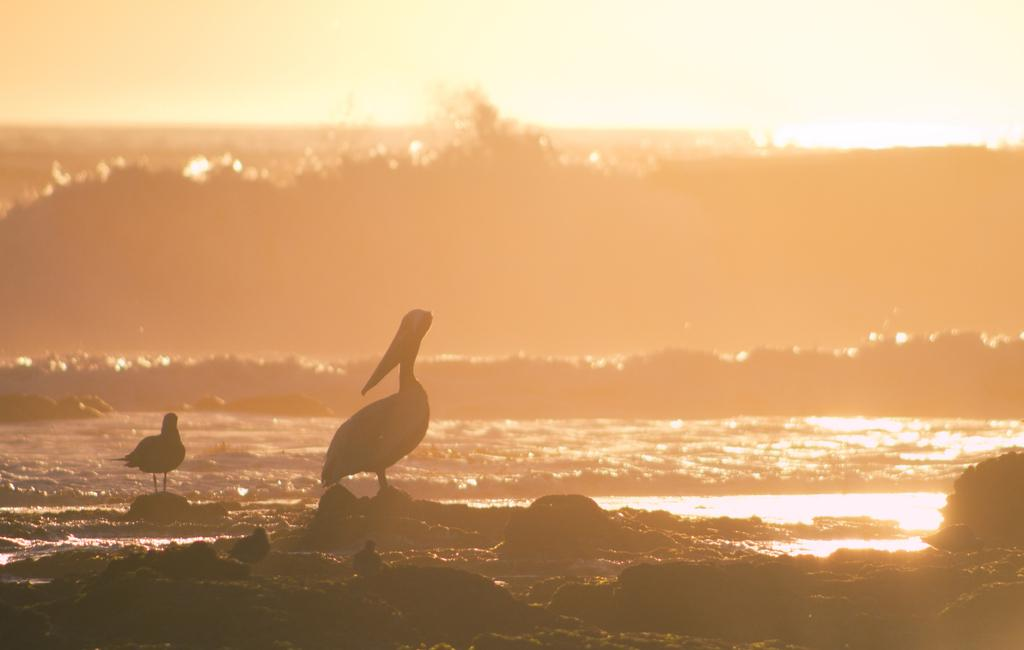What animals can be seen on the stones in the image? There are birds on the stones in the image. What can be observed in the water in the image? There are waves in the water in the image. What type of wealth is being rewarded to the birds in the image? There is no indication of wealth or rewards in the image; it simply features birds on stones and waves in the water. How many feet are visible in the image? There are no feet visible in the image. 